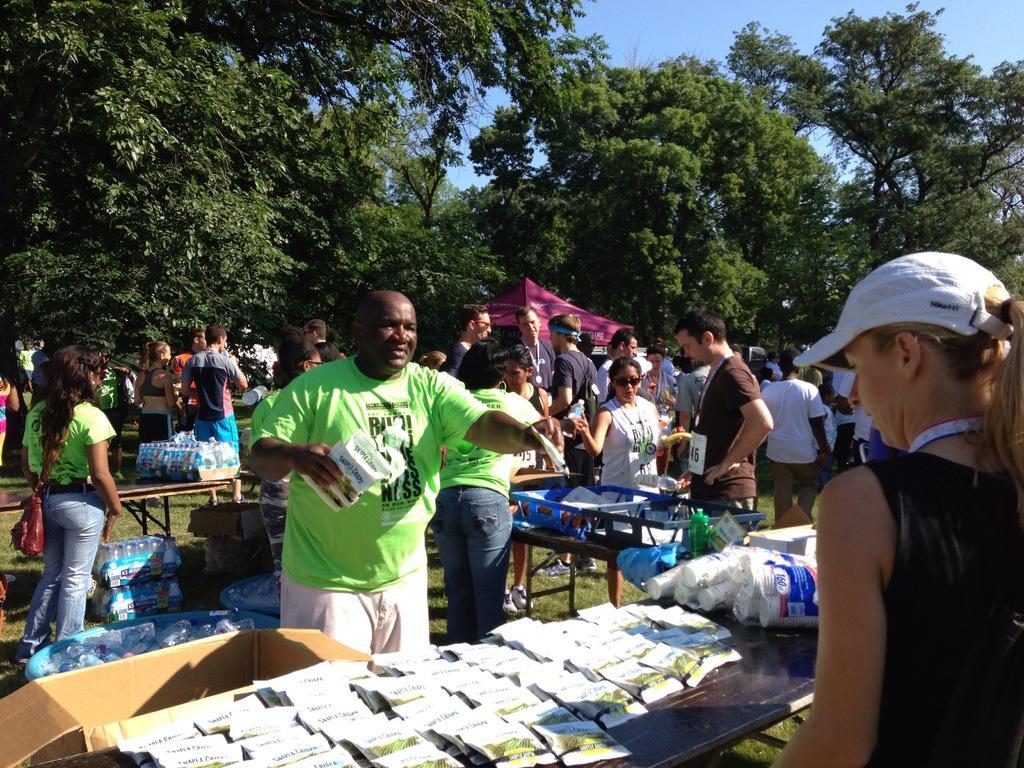In one or two sentences, can you explain what this image depicts? This picture shows few people standing and we see tables and we see a man standing and holding packets in his hand and we see a woman standing and she wore a cap on her head and we see some packets on the table and we see cups and water bottles on the another table and we see a another woman standing and she wore a handbag and we see a tent and a few of them were id cards and we see trees and a cloudy sky and a box on the ground. 